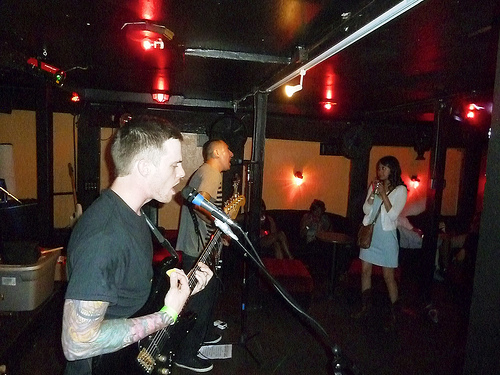<image>
Can you confirm if the lady is in front of the singing? Yes. The lady is positioned in front of the singing, appearing closer to the camera viewpoint. 